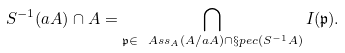Convert formula to latex. <formula><loc_0><loc_0><loc_500><loc_500>S ^ { - 1 } ( a A ) \cap A = \bigcap _ { \mathfrak { p } \in \ A s s _ { A } ( A / a A ) \cap \S p e c ( S ^ { - 1 } A ) } I ( \mathfrak { p } ) .</formula> 